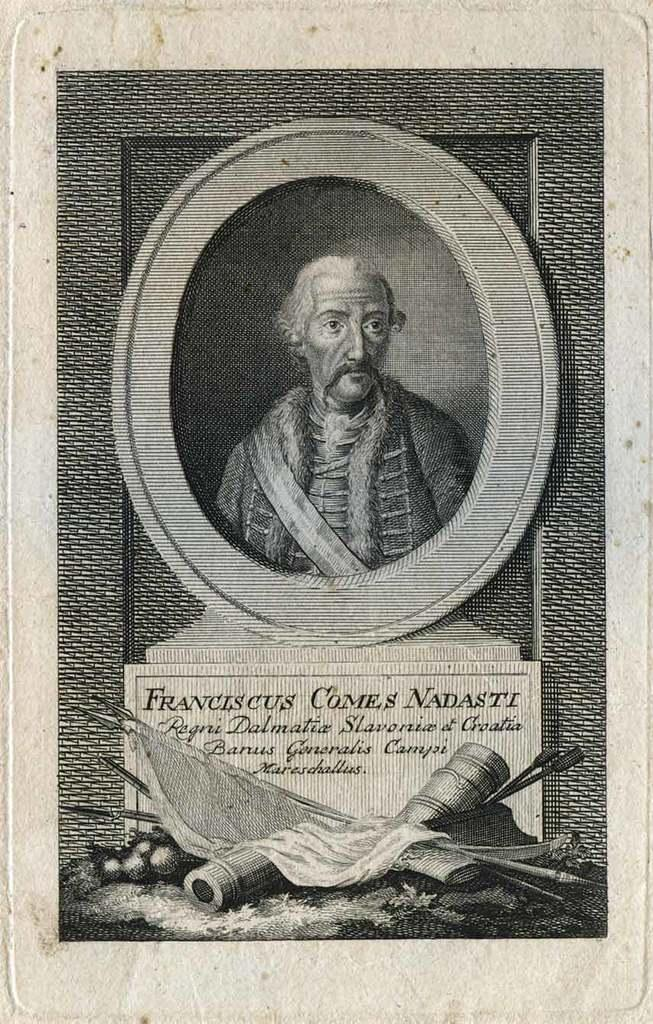What is the main subject of the image? The main subject of the image is a memorial poster of a person. Can you describe any other objects present in the image? Unfortunately, the provided facts do not specify any other objects present in the image. What color is the moon in the image? There is no moon present in the image. How does the car in the image affect the sense of the memorial poster? There is no car present in the image, so it cannot affect the sense of the memorial poster. 